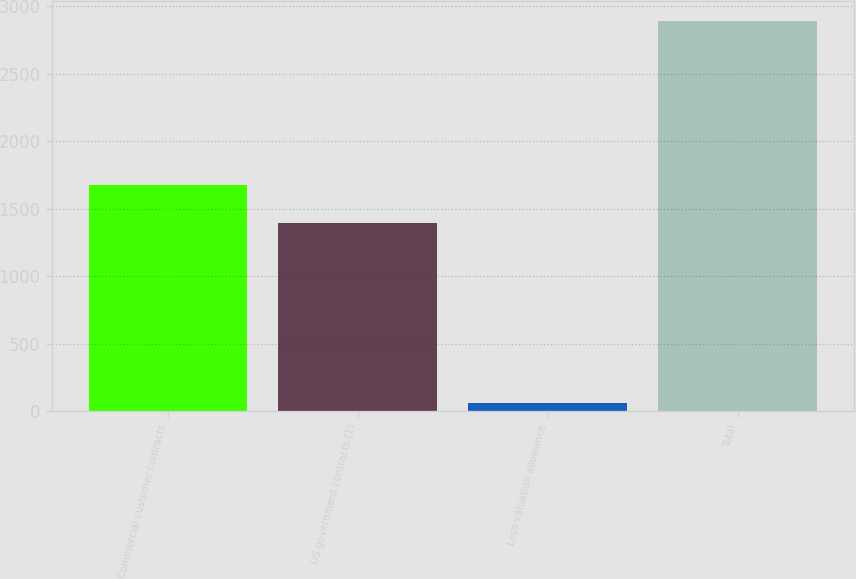Convert chart to OTSL. <chart><loc_0><loc_0><loc_500><loc_500><bar_chart><fcel>Commercial customer contracts<fcel>US government contracts (1)<fcel>Less valuation allowance<fcel>Total<nl><fcel>1679.2<fcel>1396<fcel>62<fcel>2894<nl></chart> 